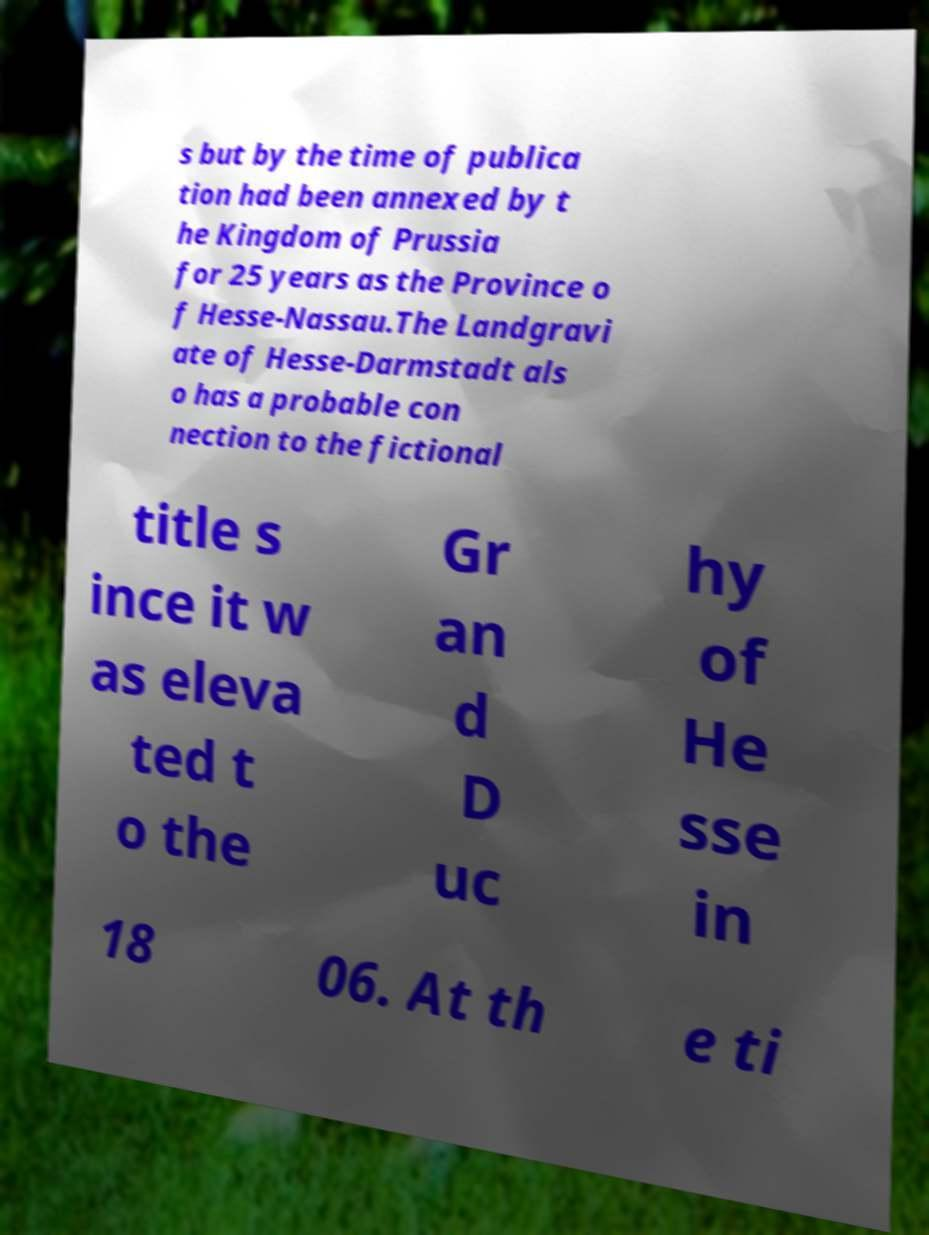Could you assist in decoding the text presented in this image and type it out clearly? s but by the time of publica tion had been annexed by t he Kingdom of Prussia for 25 years as the Province o f Hesse-Nassau.The Landgravi ate of Hesse-Darmstadt als o has a probable con nection to the fictional title s ince it w as eleva ted t o the Gr an d D uc hy of He sse in 18 06. At th e ti 